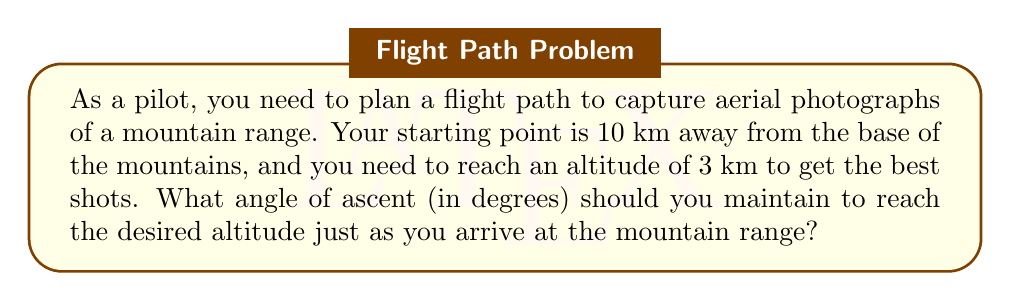Give your solution to this math problem. To solve this problem, we need to use trigonometry. Let's break it down step-by-step:

1. Visualize the problem:
   [asy]
   import geometry;
   
   size(200);
   
   pair A = (0,0);
   pair B = (10,0);
   pair C = (10,3);
   
   draw(A--B--C--A);
   
   label("10 km", (5,0), S);
   label("3 km", (10,1.5), E);
   label("θ", (0.5,0.15), NW);
   
   draw(rightanglemark(A,B,C,2));
   [/asy]

2. We have a right triangle where:
   - The adjacent side (horizontal distance) is 10 km
   - The opposite side (altitude) is 3 km
   - We need to find the angle θ

3. In a right triangle, tan(θ) = opposite / adjacent
   
   $$\tan(\theta) = \frac{3}{10}$$

4. To find θ, we need to use the inverse tangent (arctan or tan^(-1)):

   $$\theta = \arctan(\frac{3}{10})$$

5. Calculate this value:

   $$\theta = \arctan(0.3) \approx 0.2914 \text{ radians}$$

6. Convert radians to degrees:

   $$\theta \text{ (in degrees)} = 0.2914 \times \frac{180°}{\pi} \approx 16.70°$$

Therefore, the angle of ascent needed is approximately 16.70°.
Answer: The required angle of ascent is approximately 16.70°. 